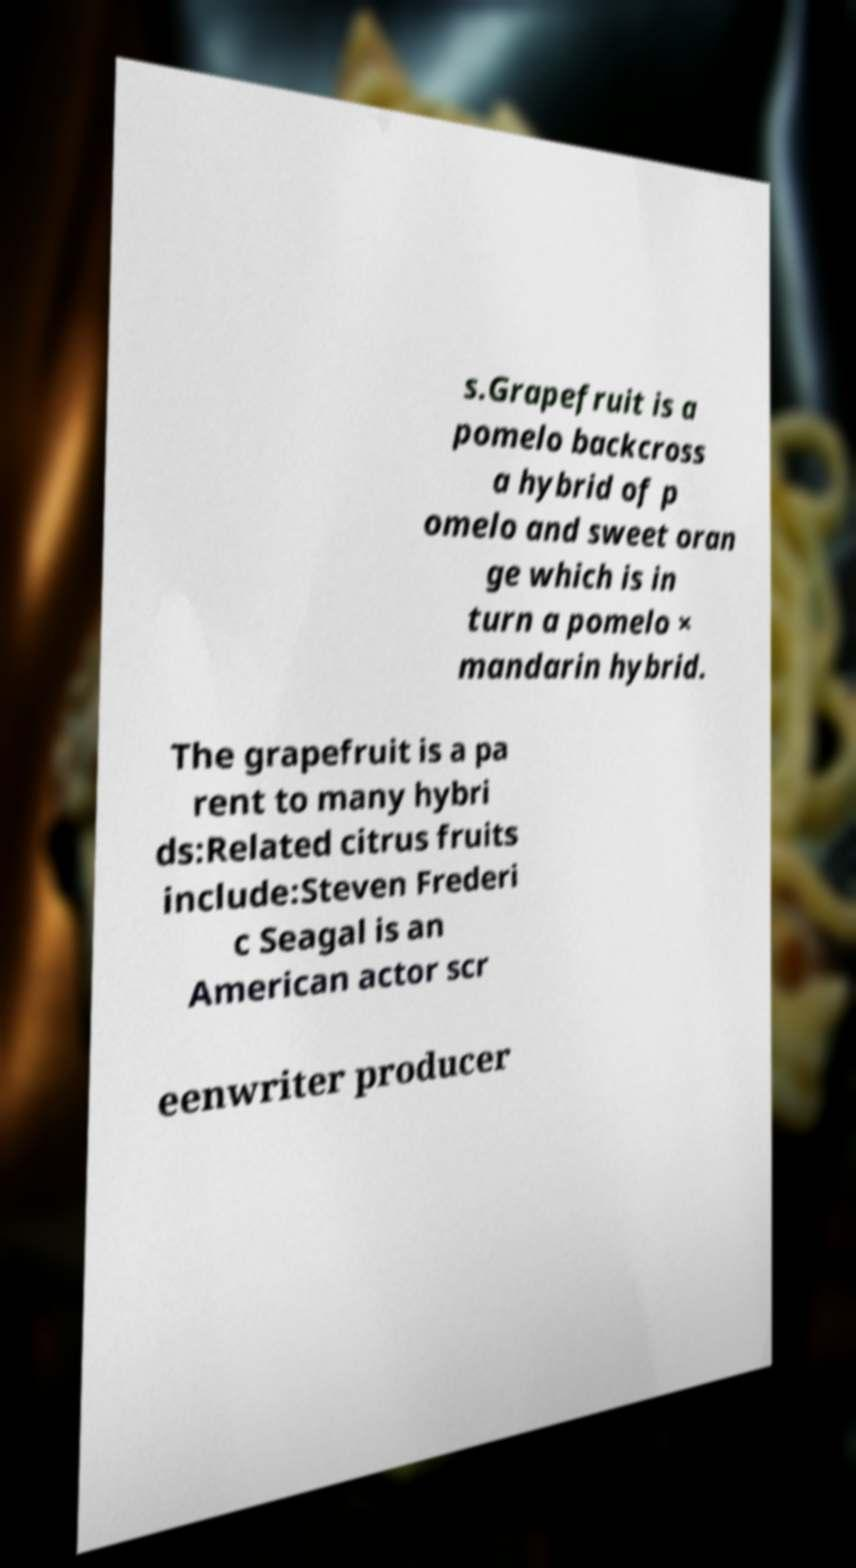Could you assist in decoding the text presented in this image and type it out clearly? s.Grapefruit is a pomelo backcross a hybrid of p omelo and sweet oran ge which is in turn a pomelo × mandarin hybrid. The grapefruit is a pa rent to many hybri ds:Related citrus fruits include:Steven Frederi c Seagal is an American actor scr eenwriter producer 